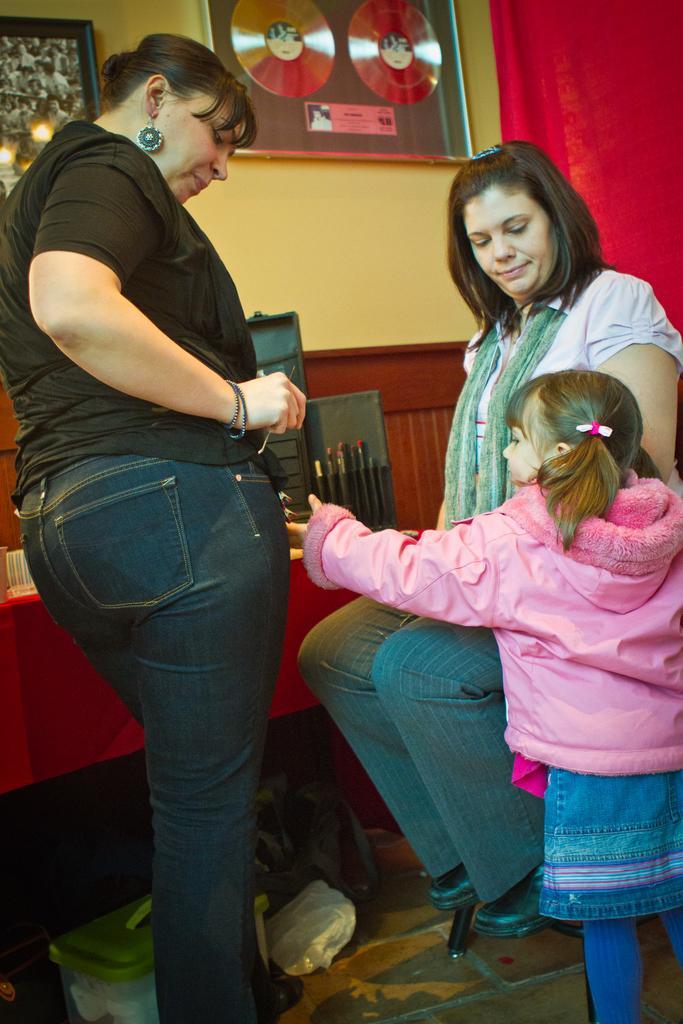Could you give a brief overview of what you see in this image? In this image we can see two women and one girl. One woman is wearing black color t-shirt with jeans. The other woman is wearing white color top, green scarf, pant and she is sitting. The girl is wearing pink color jacket. Background of the image, frames are attached to the wall, red color curtain is there and we can see one table. 